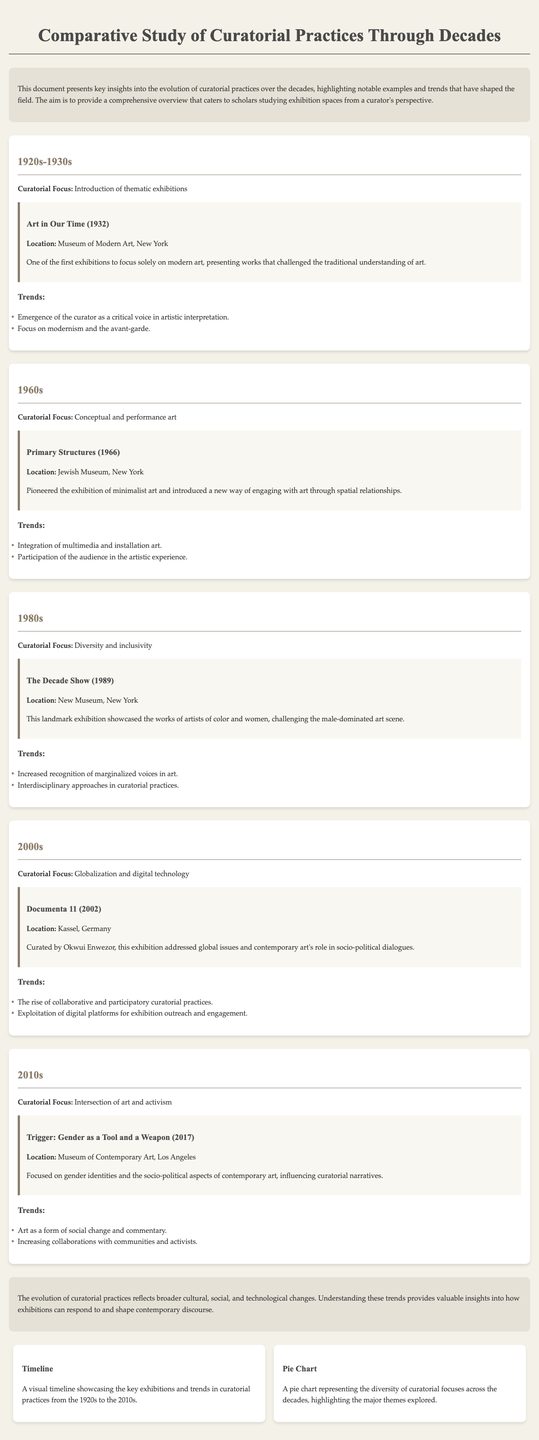What is the title of the document? The title of the document is prominently displayed at the top of the rendered page, which is "Comparative Study of Curatorial Practices Through Decades."
Answer: Comparative Study of Curatorial Practices Through Decades What was the notable exhibition in the 1980s? The document mentions a specific exhibition titled "The Decade Show" which took place in 1989.
Answer: The Decade Show Which decade introduced thematic exhibitions? The introduction of thematic exhibitions is specifically attributed to the 1920s-1930s section of the document.
Answer: 1920s-1930s Who curated Documenta 11? The document states that Okwui Enwezor curated Documenta 11, highlighting his role in this significant exhibition.
Answer: Okwui Enwezor What type of art was focused on in the 1960s? In the 1960s, the focus shifted towards conceptual and performance art, as per the descriptive section in the document.
Answer: Conceptual and performance art What trend was noted in the 2000s? The 2000s section highlights the trend of collaborative and participatory curatorial practices in exhibitions.
Answer: Collaborative and participatory practices How does the document describe the evolution of curatorial practices? The evolution is described in terms of reflecting broader cultural, social, and technological changes in society.
Answer: Reflects broader cultural, social, and technological changes What is the purpose of the infographics section? The infographics section provides visual representations of key exhibitions and trends to enhance understanding of curatorial practices.
Answer: To enhance understanding of curatorial practices Which exhibition focused on gender identities? The document specifically mentions "Trigger: Gender as a Tool and a Weapon" as the exhibition that focused on gender identities.
Answer: Trigger: Gender as a Tool and a Weapon 